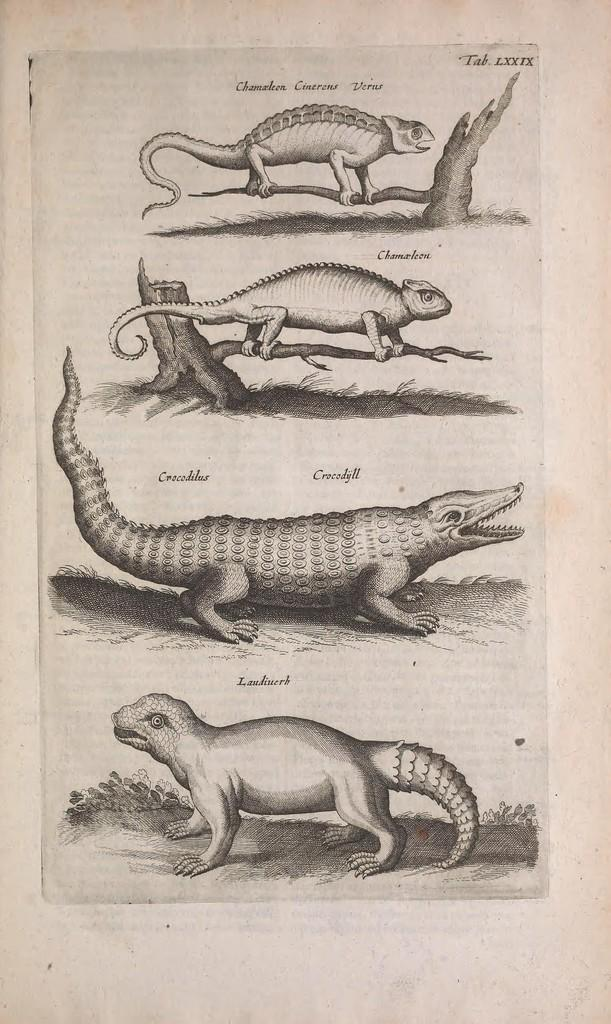What is present in the image that has a drawing on it? There is a paper in the image that has a drawing on it. Can you describe the content of the drawing on the paper? The drawing on the paper features a few animals. What type of loaf is visible in the image? There is no loaf present in the image. Is the bag visible in the image? There is no bag mentioned or visible in the image. 